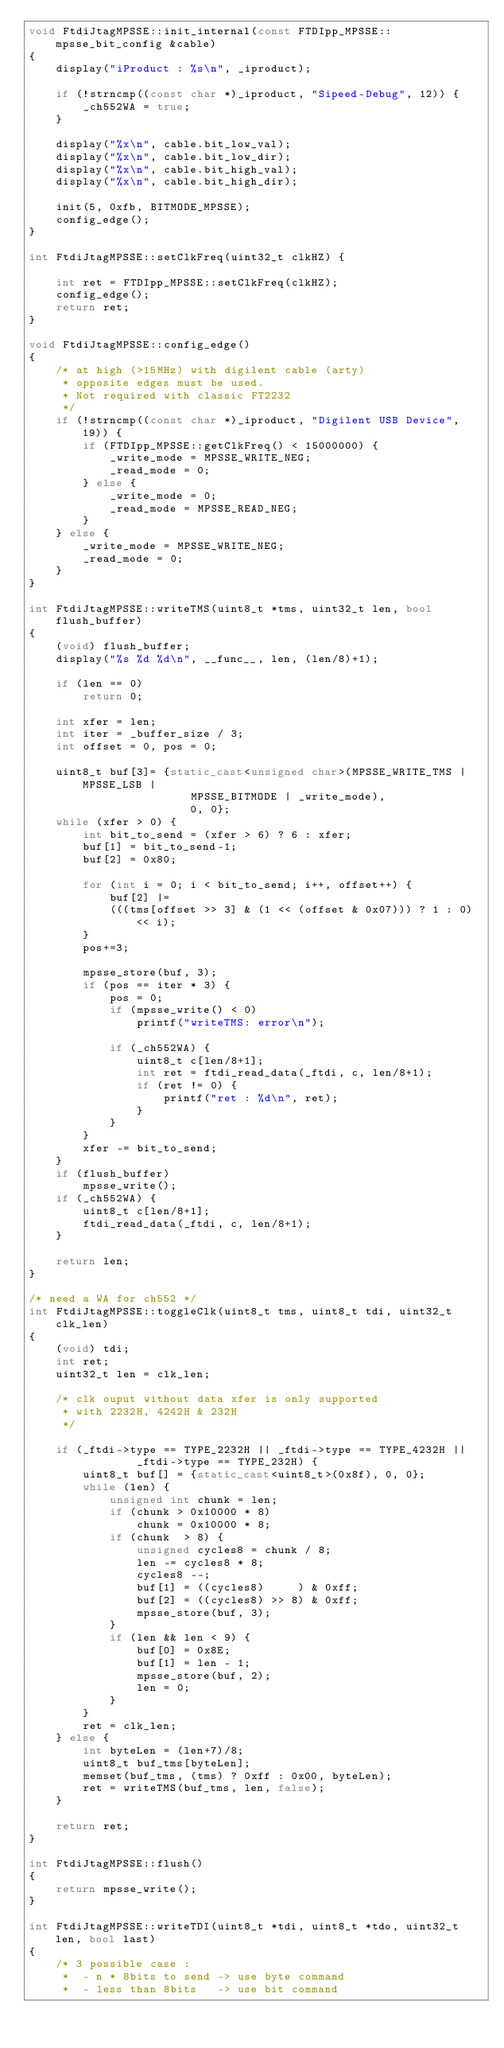<code> <loc_0><loc_0><loc_500><loc_500><_C++_>void FtdiJtagMPSSE::init_internal(const FTDIpp_MPSSE::mpsse_bit_config &cable)
{
	display("iProduct : %s\n", _iproduct);

	if (!strncmp((const char *)_iproduct, "Sipeed-Debug", 12)) {
		_ch552WA = true;
	}

	display("%x\n", cable.bit_low_val);
	display("%x\n", cable.bit_low_dir);
	display("%x\n", cable.bit_high_val);
	display("%x\n", cable.bit_high_dir);

	init(5, 0xfb, BITMODE_MPSSE);
	config_edge();
}

int FtdiJtagMPSSE::setClkFreq(uint32_t clkHZ) {

	int ret = FTDIpp_MPSSE::setClkFreq(clkHZ);
	config_edge();
	return ret;
}

void FtdiJtagMPSSE::config_edge()
{
	/* at high (>15MHz) with digilent cable (arty)
	 * opposite edges must be used.
	 * Not required with classic FT2232
	 */
	if (!strncmp((const char *)_iproduct, "Digilent USB Device", 19)) {
		if (FTDIpp_MPSSE::getClkFreq() < 15000000) {
			_write_mode = MPSSE_WRITE_NEG;
			_read_mode = 0;
		} else {
			_write_mode = 0;
			_read_mode = MPSSE_READ_NEG;
		}
	} else {
		_write_mode = MPSSE_WRITE_NEG;
		_read_mode = 0;
	}
}

int FtdiJtagMPSSE::writeTMS(uint8_t *tms, uint32_t len, bool flush_buffer)
{
	(void) flush_buffer;
	display("%s %d %d\n", __func__, len, (len/8)+1);

	if (len == 0)
		return 0;

	int xfer = len;
	int iter = _buffer_size / 3;
	int offset = 0, pos = 0;

	uint8_t buf[3]= {static_cast<unsigned char>(MPSSE_WRITE_TMS | MPSSE_LSB |
						MPSSE_BITMODE | _write_mode),
						0, 0};
	while (xfer > 0) {
		int bit_to_send = (xfer > 6) ? 6 : xfer;
		buf[1] = bit_to_send-1;
		buf[2] = 0x80;

		for (int i = 0; i < bit_to_send; i++, offset++) {
			buf[2] |=
			(((tms[offset >> 3] & (1 << (offset & 0x07))) ? 1 : 0) << i);
		}
		pos+=3;

		mpsse_store(buf, 3);
		if (pos == iter * 3) {
			pos = 0;
			if (mpsse_write() < 0)
				printf("writeTMS: error\n");

			if (_ch552WA) {
				uint8_t c[len/8+1];
				int ret = ftdi_read_data(_ftdi, c, len/8+1);
				if (ret != 0) {
					printf("ret : %d\n", ret);
				}
			}
		}
		xfer -= bit_to_send;
	}
	if (flush_buffer)
		mpsse_write();
	if (_ch552WA) {
		uint8_t c[len/8+1];
		ftdi_read_data(_ftdi, c, len/8+1);
	}

	return len;
}

/* need a WA for ch552 */
int FtdiJtagMPSSE::toggleClk(uint8_t tms, uint8_t tdi, uint32_t clk_len)
{
	(void) tdi;
	int ret;
	uint32_t len = clk_len;

	/* clk ouput without data xfer is only supported
	 * with 2232H, 4242H & 232H
	 */

	if (_ftdi->type == TYPE_2232H || _ftdi->type == TYPE_4232H ||
				_ftdi->type == TYPE_232H) {
		uint8_t buf[] = {static_cast<uint8_t>(0x8f), 0, 0};
		while (len) {
			unsigned int chunk = len;
			if (chunk > 0x10000 * 8)
				chunk = 0x10000 * 8;
			if (chunk  > 8) {
				unsigned cycles8 = chunk / 8;
				len -= cycles8 * 8;
				cycles8 --;
				buf[1] = ((cycles8)		) & 0xff;
				buf[2] = ((cycles8) >> 8) & 0xff;
				mpsse_store(buf, 3);
			}
			if (len && len < 9) {
				buf[0] = 0x8E;
				buf[1] = len - 1;
				mpsse_store(buf, 2);
				len = 0;
			}
		}
		ret = clk_len;
	} else {
		int byteLen = (len+7)/8;
		uint8_t buf_tms[byteLen];
		memset(buf_tms, (tms) ? 0xff : 0x00, byteLen);
		ret = writeTMS(buf_tms, len, false);
	}

	return ret;
}

int FtdiJtagMPSSE::flush()
{
	return mpsse_write();
}

int FtdiJtagMPSSE::writeTDI(uint8_t *tdi, uint8_t *tdo, uint32_t len, bool last)
{
	/* 3 possible case :
	 *  - n * 8bits to send -> use byte command
	 *  - less than 8bits   -> use bit command</code> 